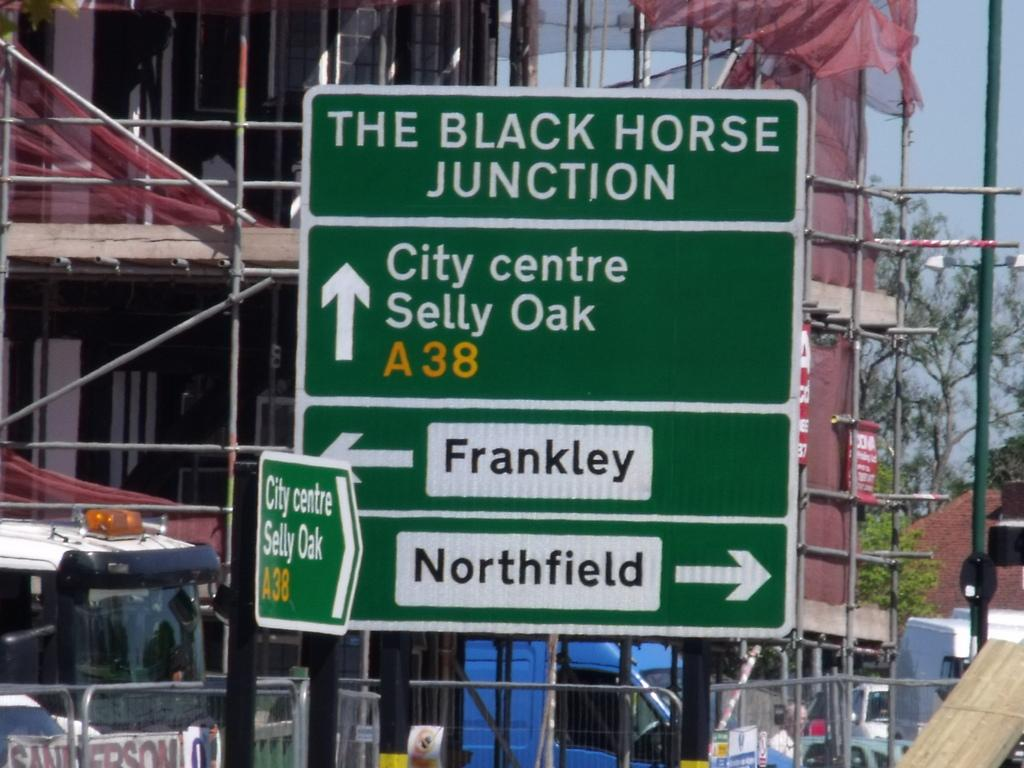What structures are present in the image? There are poles, boards, and a building in the image. What type of vehicles can be seen in the image? There are vehicles in the image. What additional items are present in the image? There are banners and trees in the image. What can be seen in the background of the image? The sky is visible in the background of the image. What type of hair can be seen on the trees in the image? There is no hair present on the trees in the image; they are covered with leaves and branches. Is there a yard visible in the image? There is no yard mentioned or visible in the image; it features poles, boards, vehicles, banners, trees, a building, and the sky. 